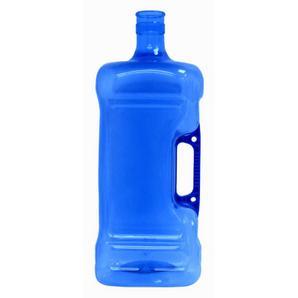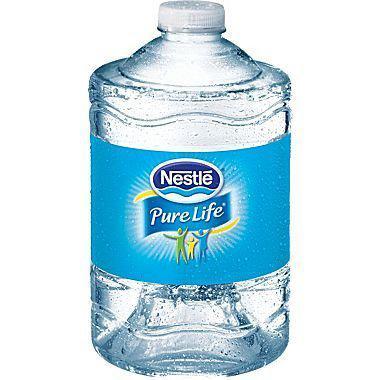The first image is the image on the left, the second image is the image on the right. For the images displayed, is the sentence "There is at least three containers with lids on them." factually correct? Answer yes or no. No. 